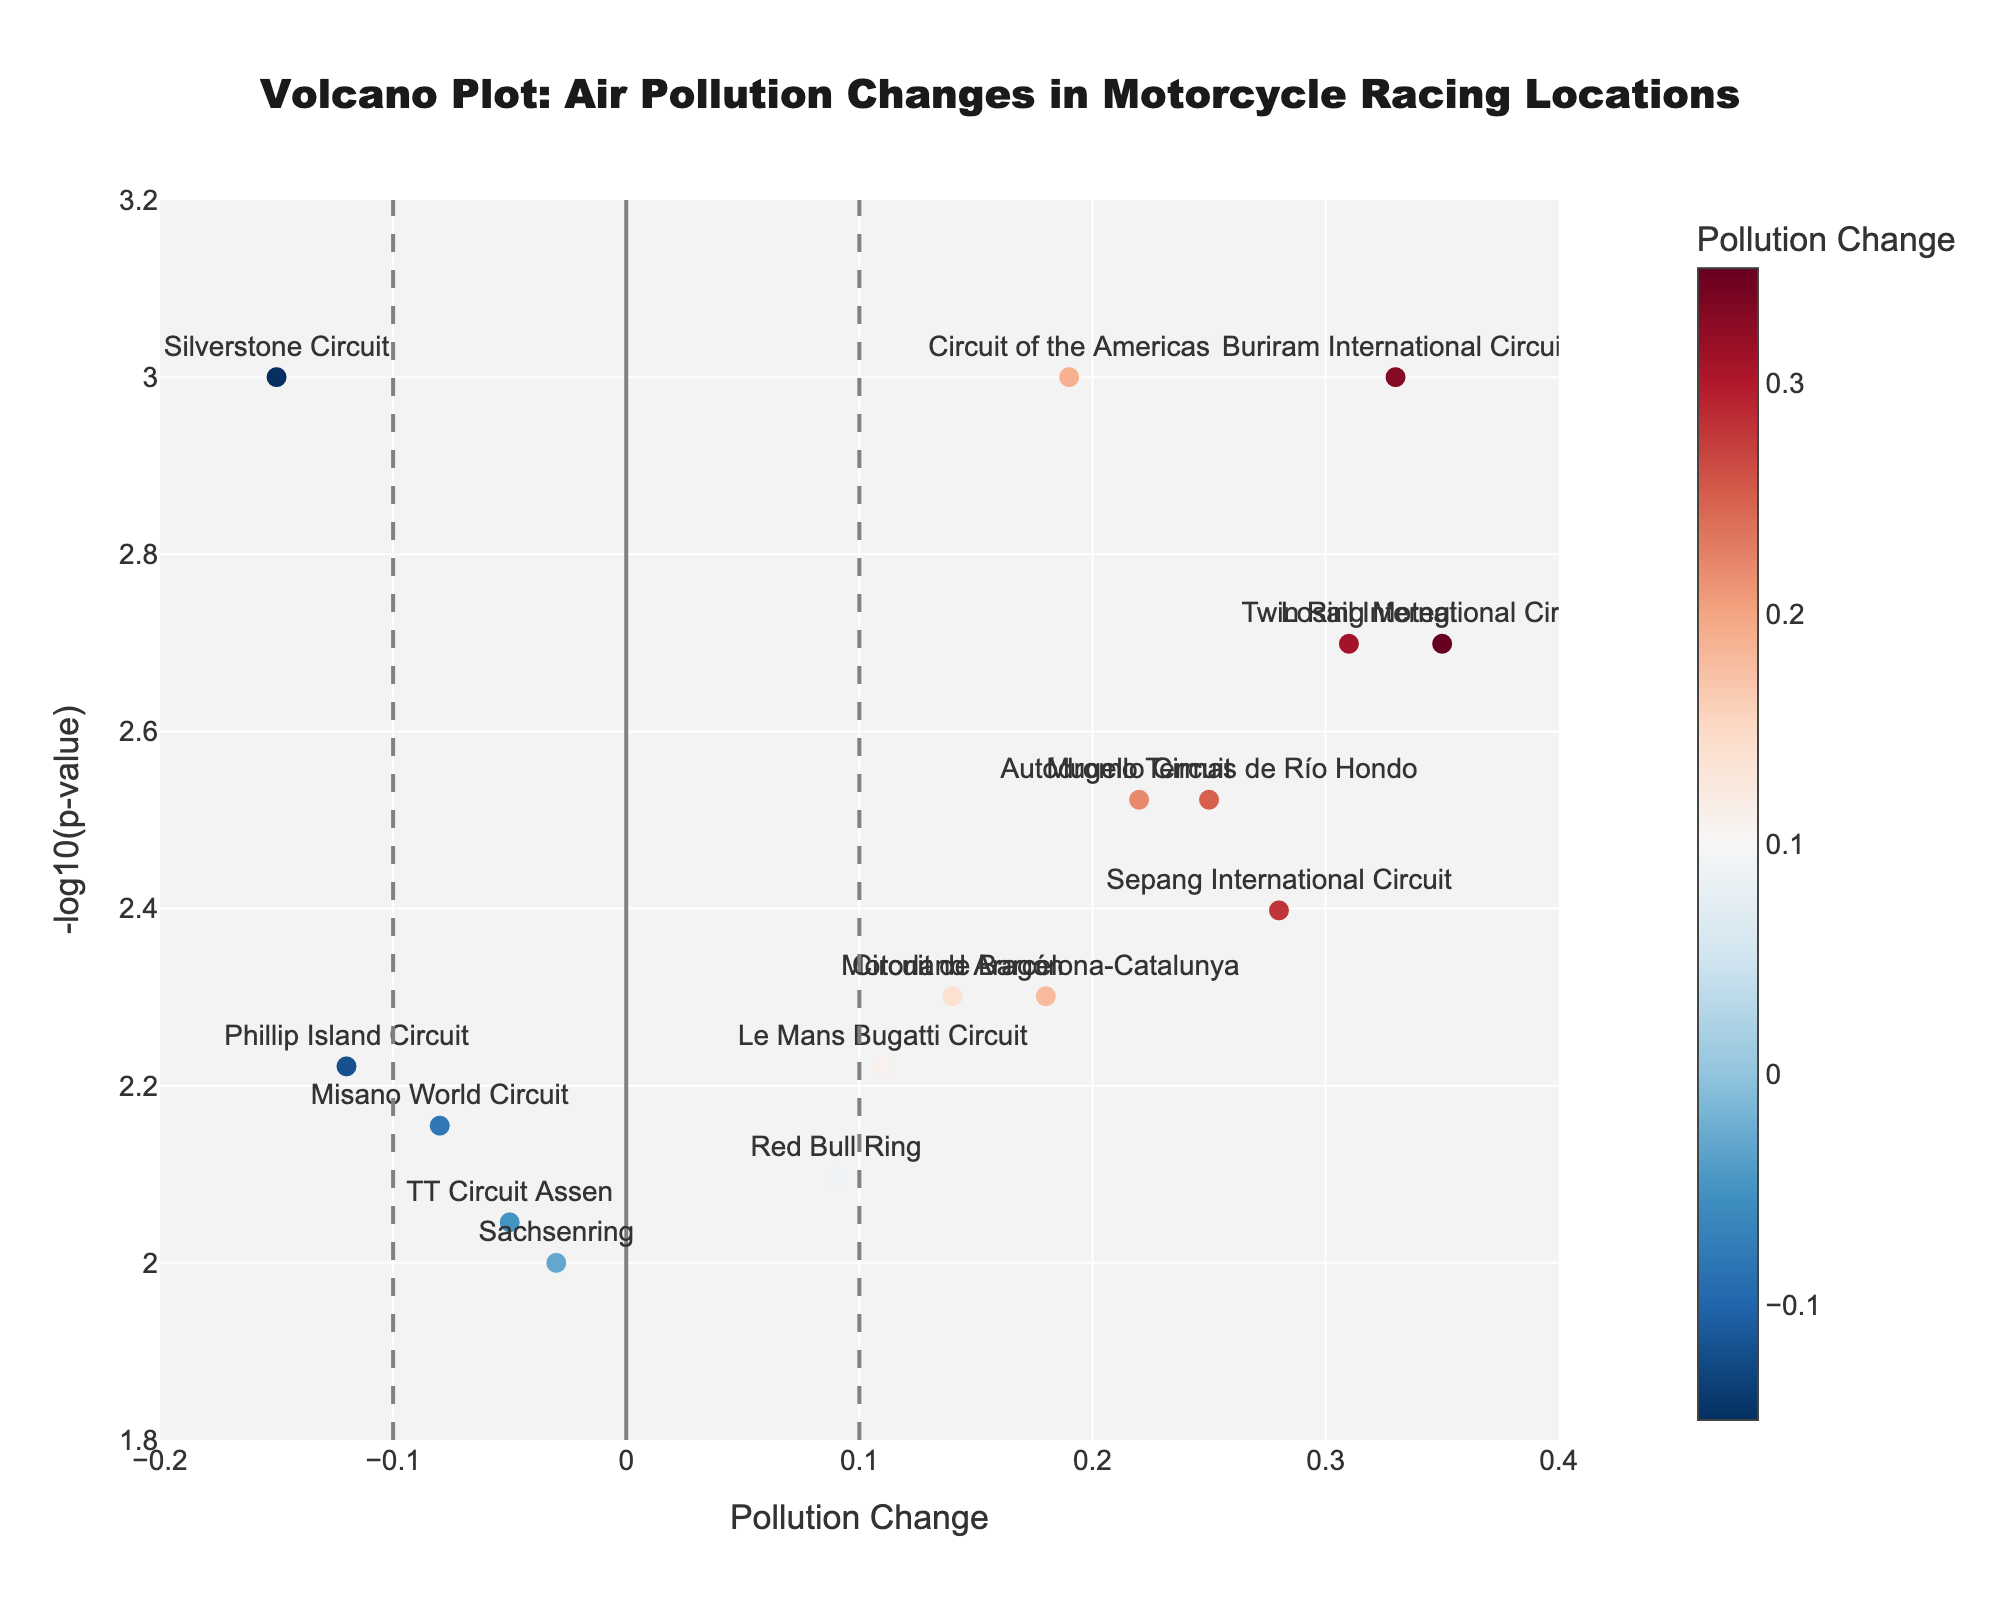How many racing locations show a decrease in air pollution? By looking at the points on the left side of the vertical line at x = 0, we can count how many are below the horizontal line. There are four locations with negative pollution change values
Answer: 4 Which location has the highest increase in air pollution? By looking at the point farthest to the right, Buriram International Circuit has the highest increase in air pollution (0.33)
Answer: Buriram International Circuit Which locations have a p-value less than 0.002? By checking the points above the y = 3.0 horizontal line, there are three locations: Losail International Circuit, Circuit of the Americas, and Buriram International Circuit
Answer: Losail International Circuit, Circuit of the Americas, Buriram International Circuit What is the pollution change value for Silverstone Circuit? Locate the text label for Silverstone Circuit on the plot, and the x coordinate for this point is -0.15
Answer: -0.15 Which location has the lowest -log10(p-value)? The lowest y value indicates the highest p-value, so Sachsenring has the lowest -log10(p-value)
Answer: Sachsenring How many locations have a significant pollution change at a p-value threshold of 0.05? The significant locations are above the horizontal dashed red line at y=-log10(0.05), indicated as y=1.3010. Counting all the points above this line, we find 16 such locations
Answer: 16 Which two locations have a pollution change closest to zero? By finding the points closest to the vertical line at x=0, Sachsenring (-0.03) and TT Circuit Assen (-0.05) are the closest
Answer: Sachsenring and TT Circuit Assen What is the range of pollution change values on the x-axis of the plot? The minimum value on the x-axis is -0.2, and the maximum value is 0.4, as shown by the labeled range of the x-axis
Answer: -0.2 to 0.4 How is the significance of pollution change represented in this plot? Significance is represented by the y-axis value, which is -log10(p-value). The higher the value on the y-axis, the more significant the pollution change
Answer: Higher y-axis values indicate more significant pollution change 